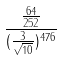Convert formula to latex. <formula><loc_0><loc_0><loc_500><loc_500>\frac { \frac { 6 4 } { 2 5 2 } } { ( \frac { 3 } { \sqrt { 1 0 } } ) ^ { 4 7 6 } }</formula> 